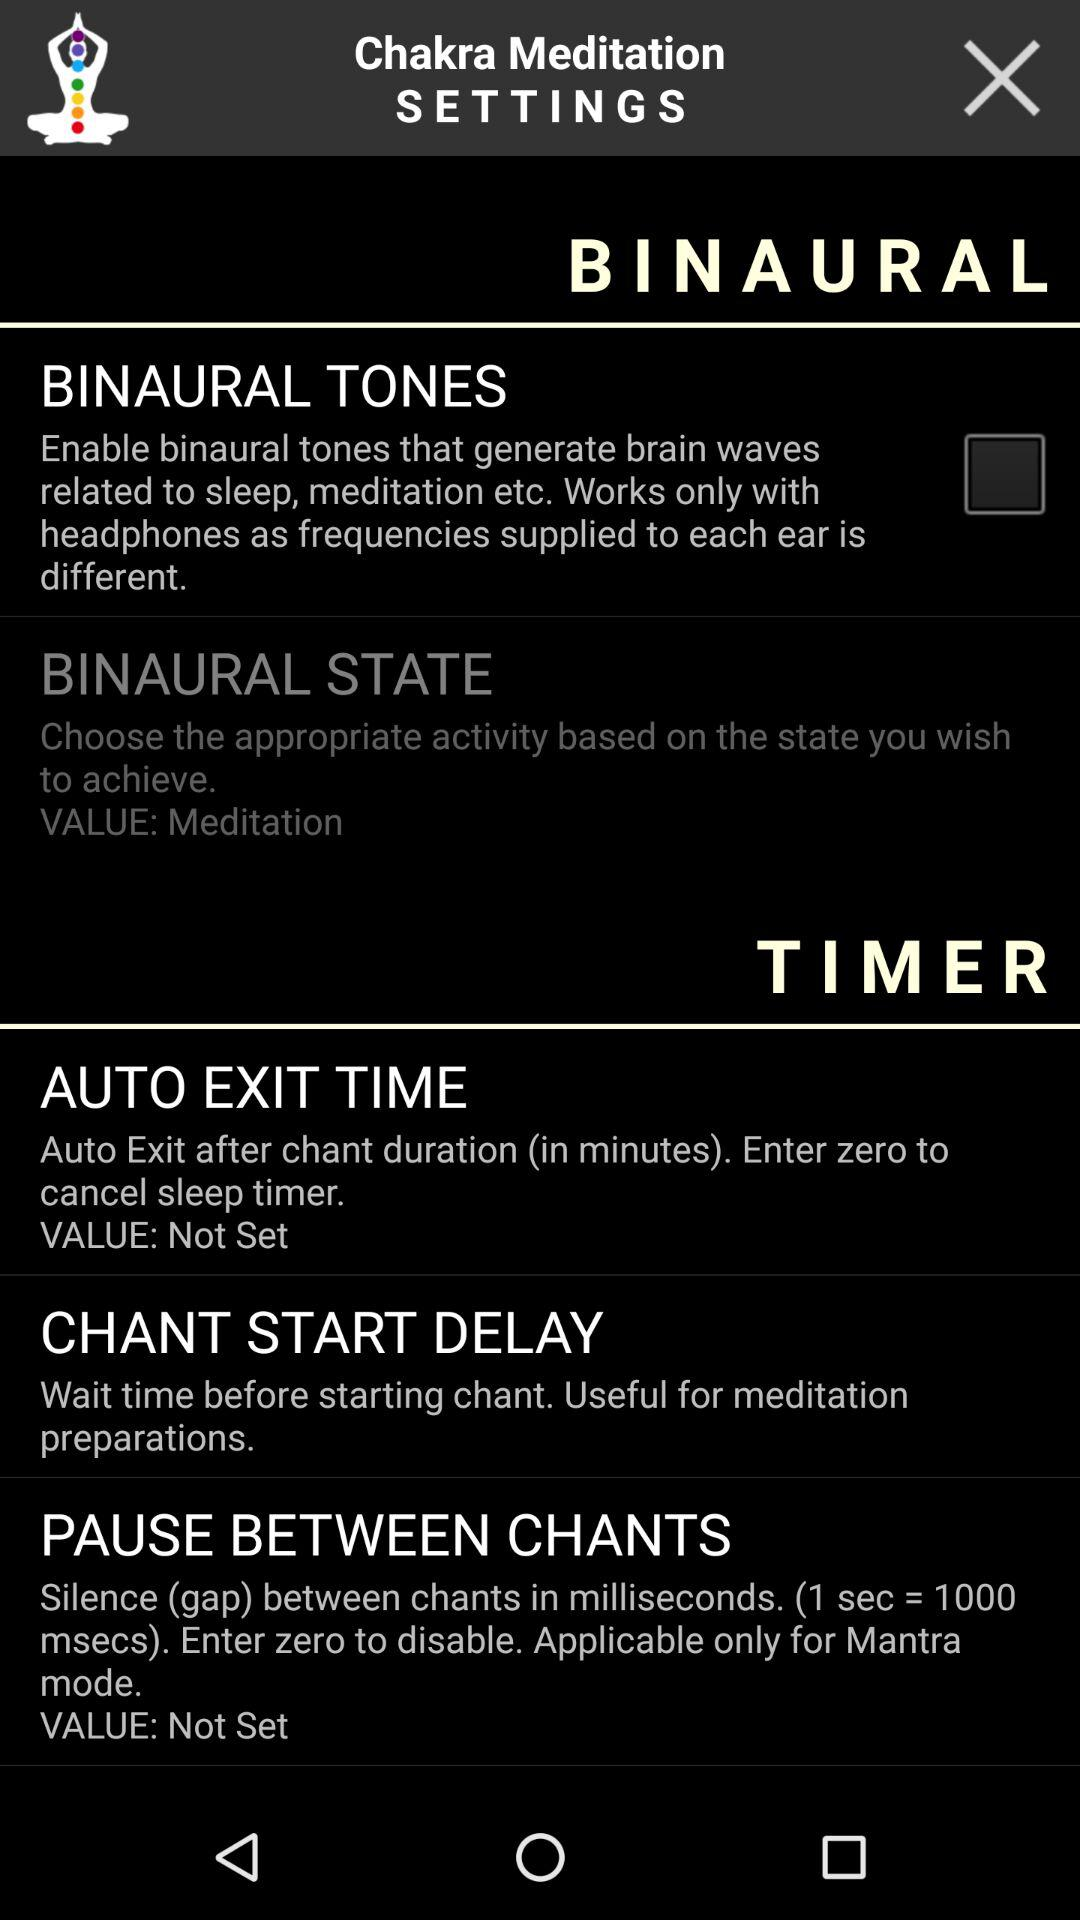What is the status of "Binaural tones"? The status is "off". 